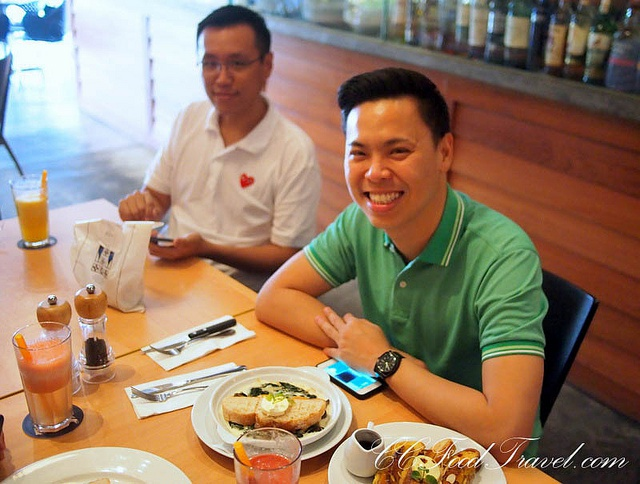Describe the objects in this image and their specific colors. I can see dining table in lightblue, orange, lightgray, and tan tones, people in lightblue, brown, darkgreen, green, and black tones, people in lightblue, tan, maroon, and brown tones, bowl in lightblue, tan, and beige tones, and cup in lightblue, brown, tan, red, and salmon tones in this image. 